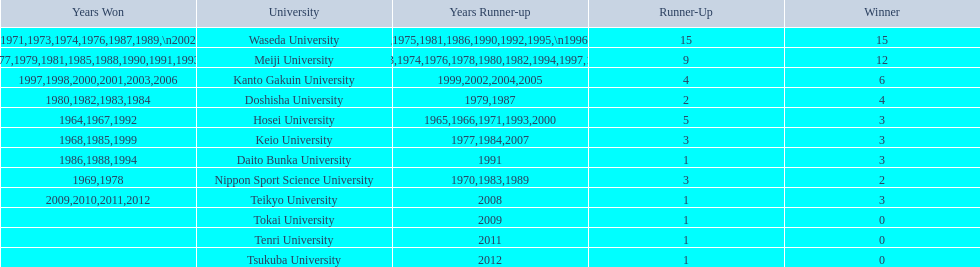What university were there in the all-japan university rugby championship? Waseda University, Meiji University, Kanto Gakuin University, Doshisha University, Hosei University, Keio University, Daito Bunka University, Nippon Sport Science University, Teikyo University, Tokai University, Tenri University, Tsukuba University. Of these who had more than 12 wins? Waseda University. 